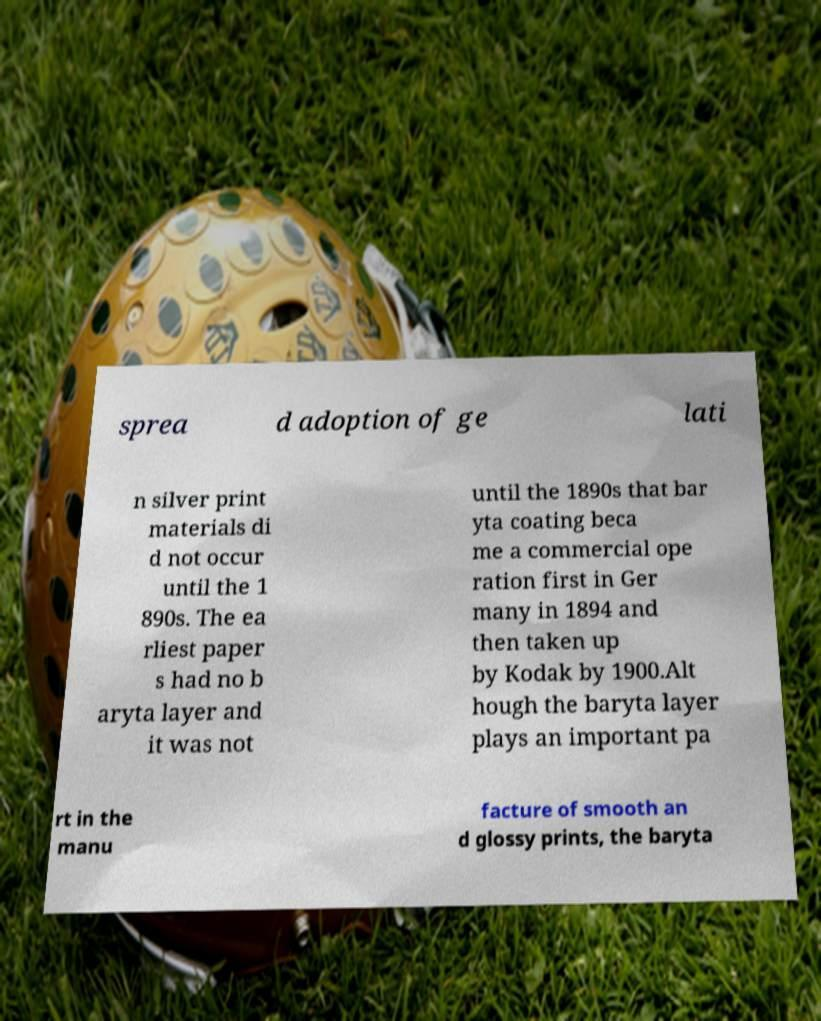What messages or text are displayed in this image? I need them in a readable, typed format. sprea d adoption of ge lati n silver print materials di d not occur until the 1 890s. The ea rliest paper s had no b aryta layer and it was not until the 1890s that bar yta coating beca me a commercial ope ration first in Ger many in 1894 and then taken up by Kodak by 1900.Alt hough the baryta layer plays an important pa rt in the manu facture of smooth an d glossy prints, the baryta 